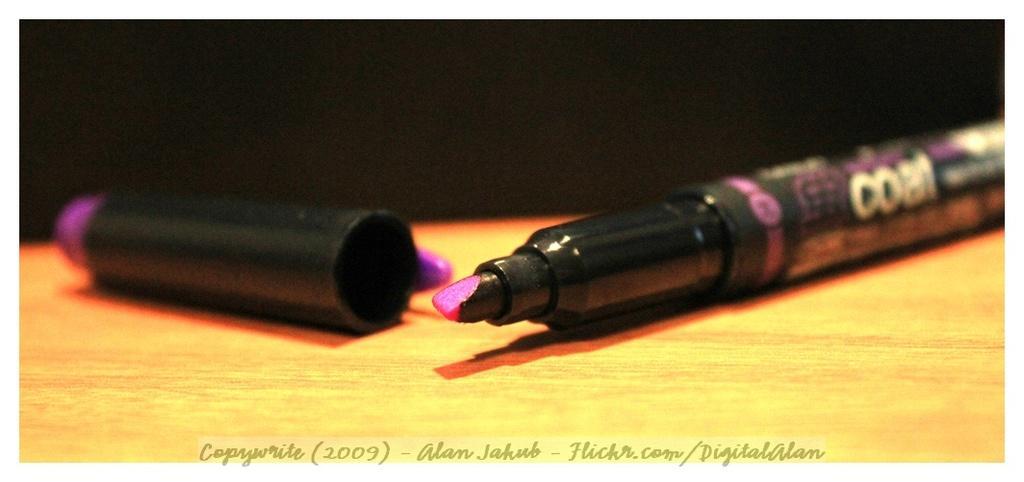Describe this image in one or two sentences. On the right side of this image there is a marker pen placed on a wooden surface and its cap is on the left side. The background is in black color. At the bottom of this image I can see some edited text. 